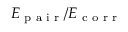<formula> <loc_0><loc_0><loc_500><loc_500>E _ { p a i r } / E _ { c o r r }</formula> 